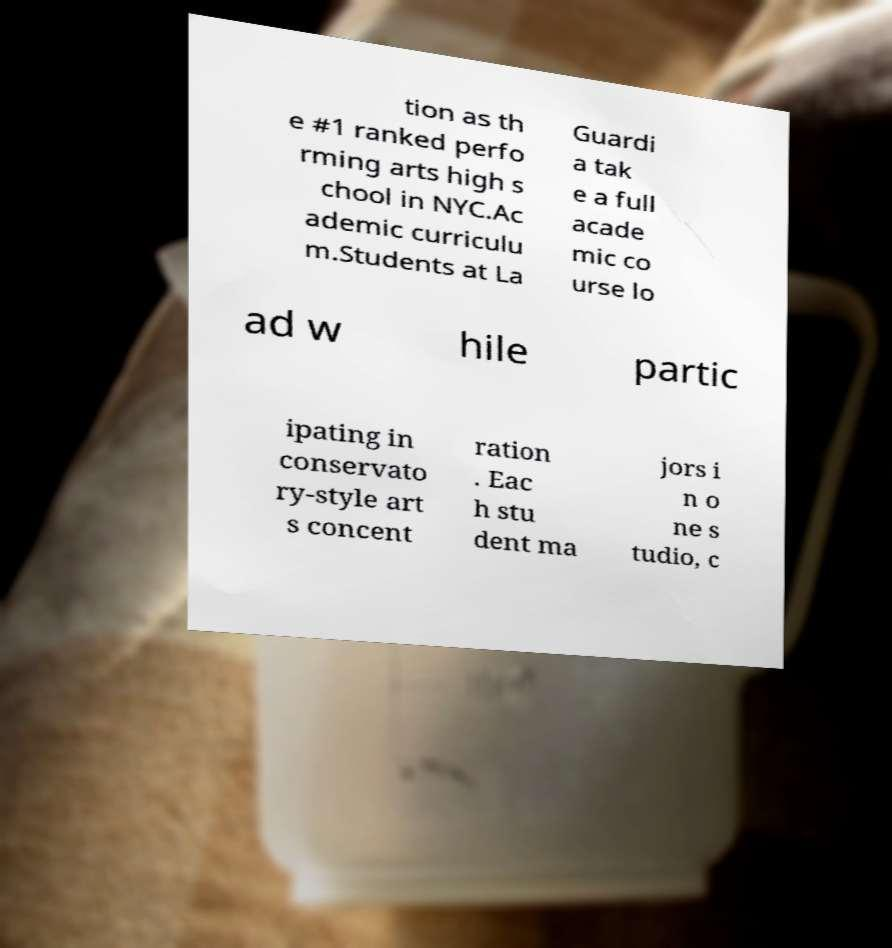There's text embedded in this image that I need extracted. Can you transcribe it verbatim? tion as th e #1 ranked perfo rming arts high s chool in NYC.Ac ademic curriculu m.Students at La Guardi a tak e a full acade mic co urse lo ad w hile partic ipating in conservato ry-style art s concent ration . Eac h stu dent ma jors i n o ne s tudio, c 